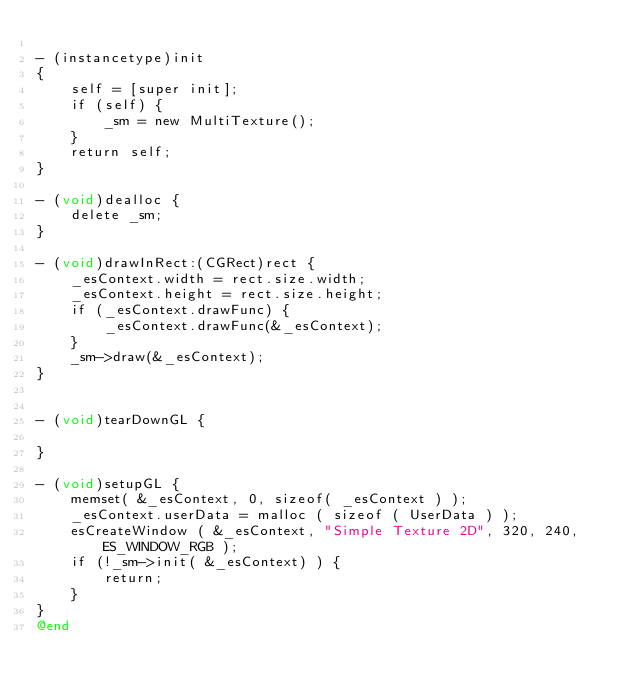<code> <loc_0><loc_0><loc_500><loc_500><_ObjectiveC_>
- (instancetype)init
{
    self = [super init];
    if (self) {
        _sm = new MultiTexture();
    }
    return self;
}

- (void)dealloc {
    delete _sm;
}

- (void)drawInRect:(CGRect)rect {
    _esContext.width = rect.size.width;
    _esContext.height = rect.size.height;
    if (_esContext.drawFunc) {
        _esContext.drawFunc(&_esContext);
    }
    _sm->draw(&_esContext);
}


- (void)tearDownGL {
    
}

- (void)setupGL {
    memset( &_esContext, 0, sizeof( _esContext ) );
    _esContext.userData = malloc ( sizeof ( UserData ) );
    esCreateWindow ( &_esContext, "Simple Texture 2D", 320, 240, ES_WINDOW_RGB );
    if (!_sm->init( &_esContext) ) {
        return;
    }
}
@end
</code> 